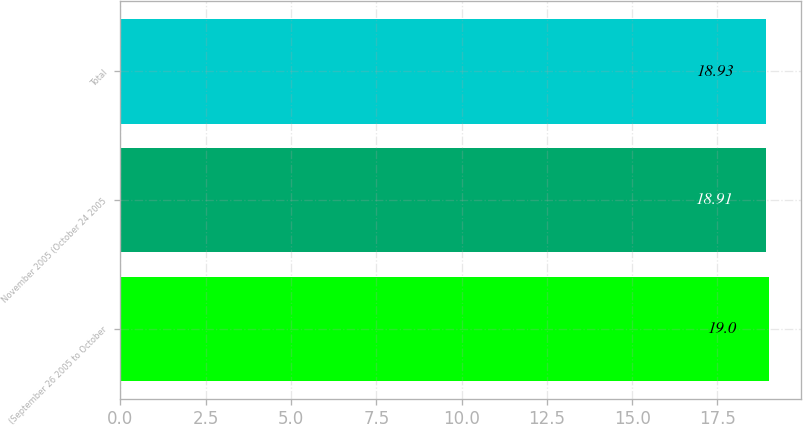Convert chart to OTSL. <chart><loc_0><loc_0><loc_500><loc_500><bar_chart><fcel>(September 26 2005 to October<fcel>November 2005 (October 24 2005<fcel>Total<nl><fcel>19<fcel>18.91<fcel>18.93<nl></chart> 